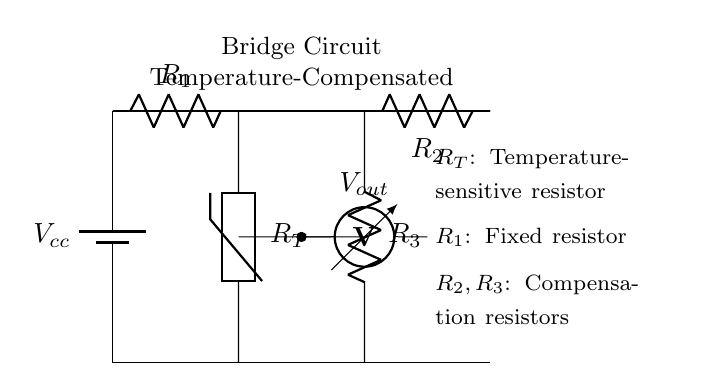What type of component is R_T? R_T is a thermistor, which is a type of temperature-sensitive resistor used to change resistance based on temperature.
Answer: Thermistor What are R_2 and R_3 used for? R_2 and R_3 are compensation resistors that help maintain the bridge balance and mitigate effects from changes in temperature.
Answer: Compensation resistors Is there an output voltage measurement in the circuit? Yes, the voltmeter measures output voltage, represented as V_out, which indicates the differential voltage across the bridge circuit.
Answer: Yes What is the purpose of the voltage source in the circuit? The voltage source, V_cc, provides the necessary power supply for the operation of the bridge circuit and enables current to flow through the resistors.
Answer: Power supply How many resistors are in the circuit? There are three resistors: R_1, R_2, and R_3, as well as the thermistor R_T, making a total of four resistive components.
Answer: Four What is the function of the short connections in the circuit? The short connections join different parts of the circuit to allow current to flow from R_T and R_3 to the voltmeter, facilitating voltage measurement.
Answer: Current flow What type of circuit is represented? The circuit is a temperature-compensated bridge circuit, designed to measure temperature-related changes accurately in agricultural environments.
Answer: Bridge circuit 